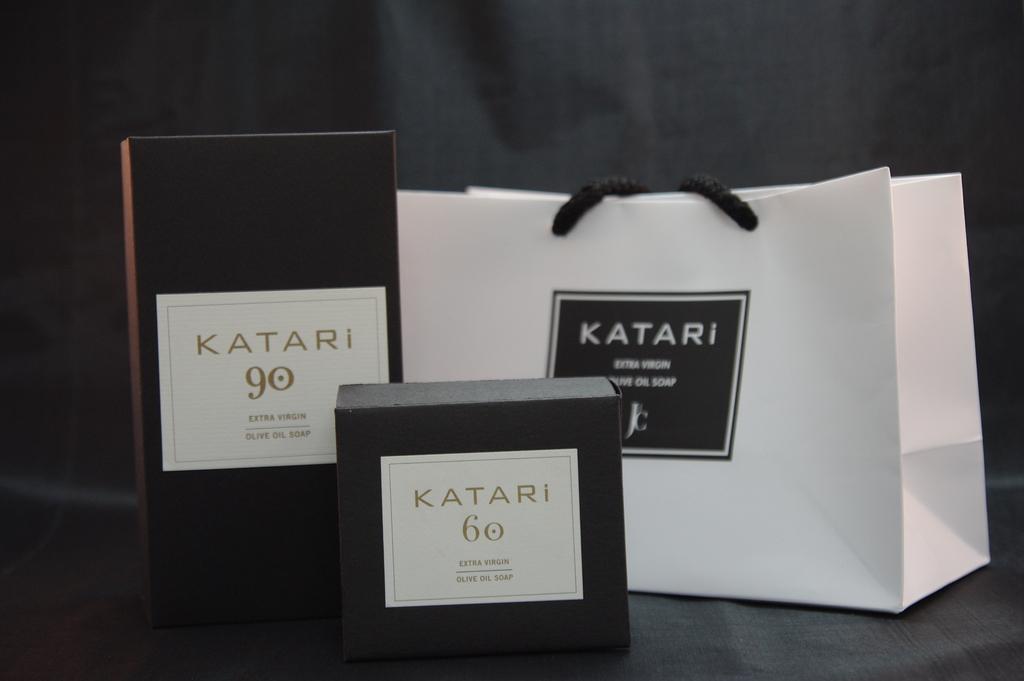Are these by katari?
Provide a succinct answer. Yes. What brand are these?
Give a very brief answer. Katari. 